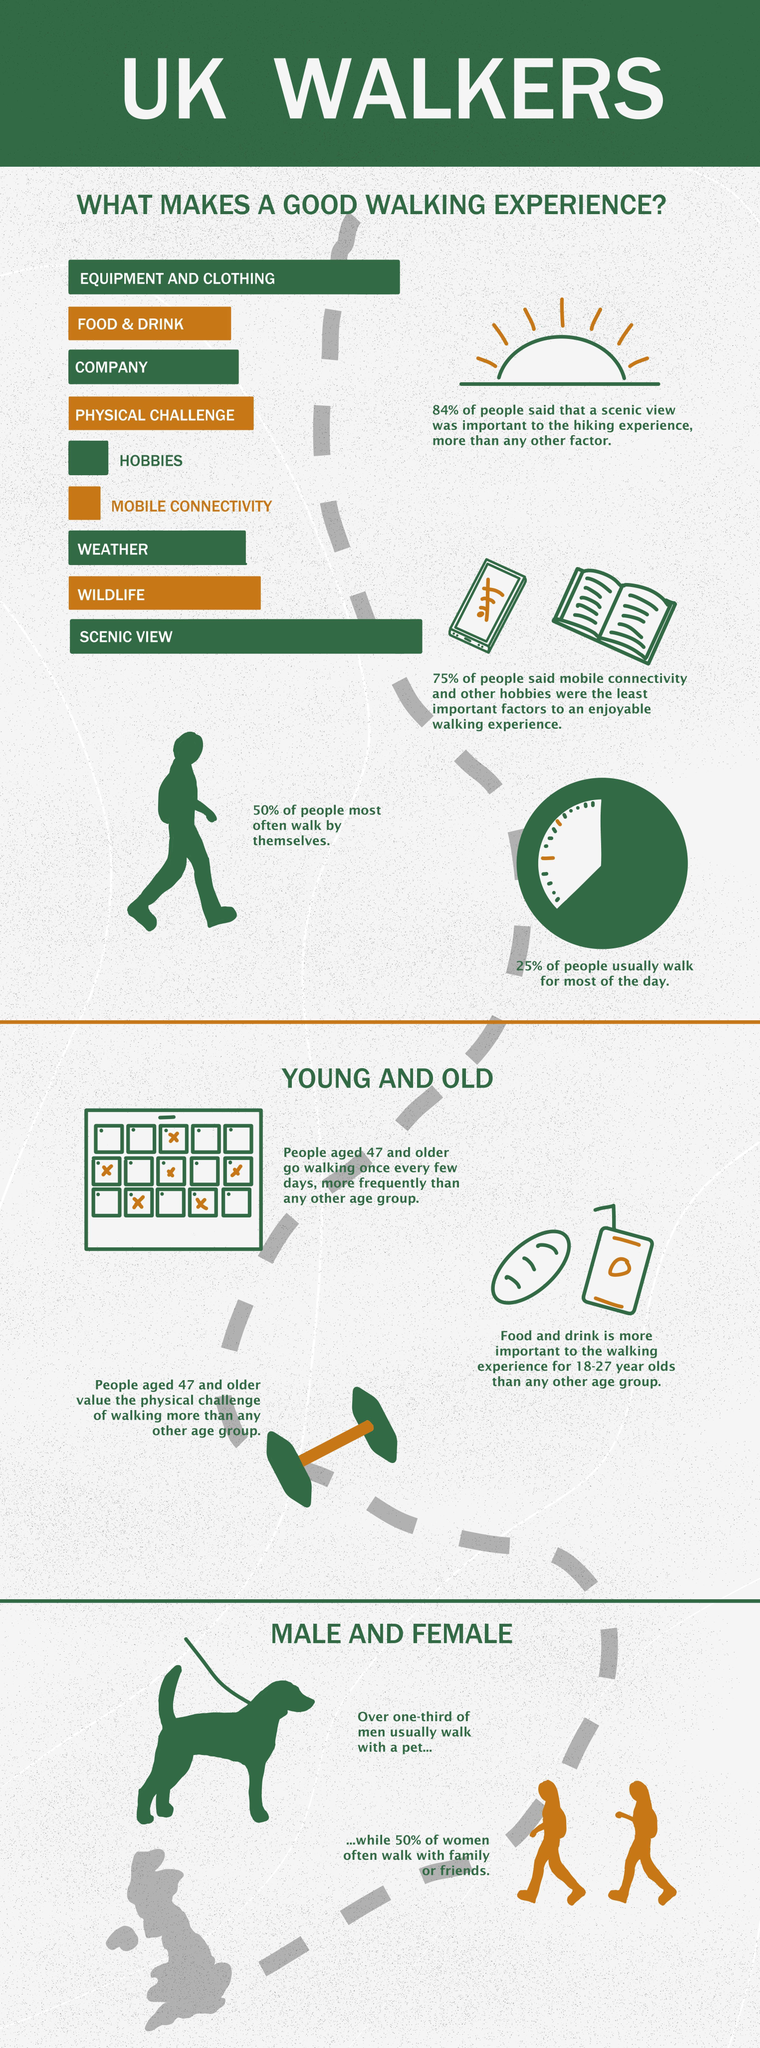What is the second most important factor that makes a good walking experience?
Answer the question with a short phrase. Equipment and clothing How many factors that make a good walking experience are listed in the infographic? 9 What percent of men usually walk with a pet? 33.33% What is the most important factor that makes a good walking experience? Scenic View 